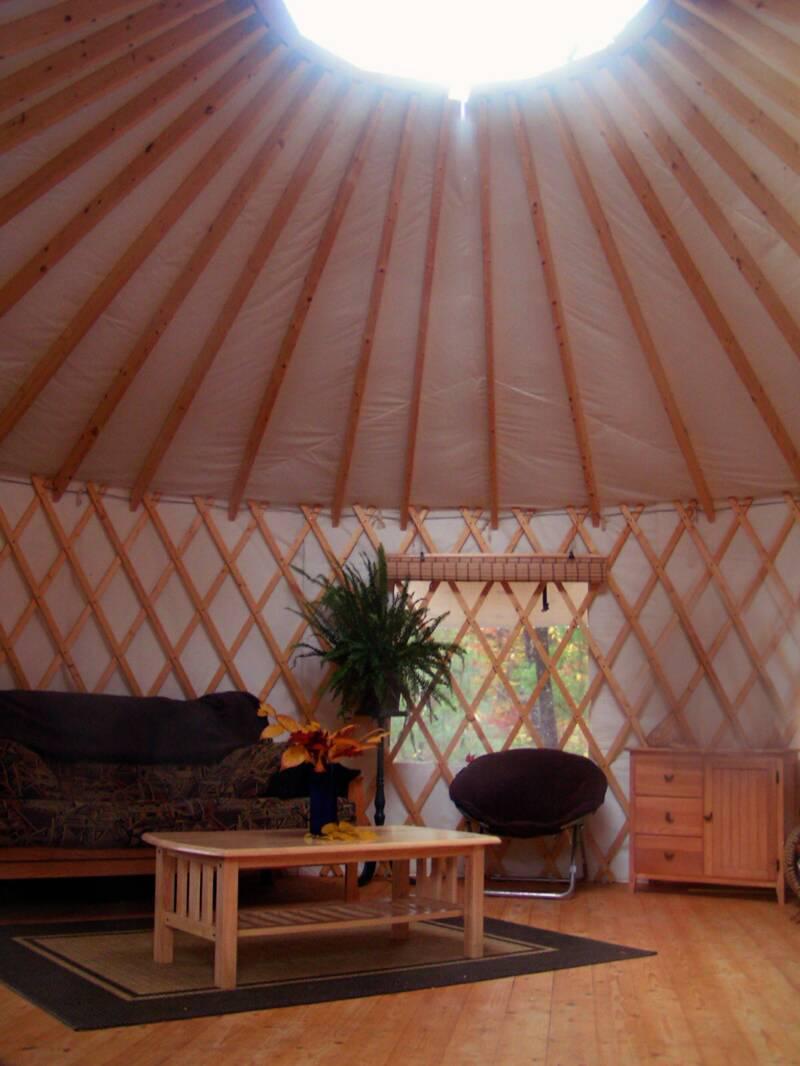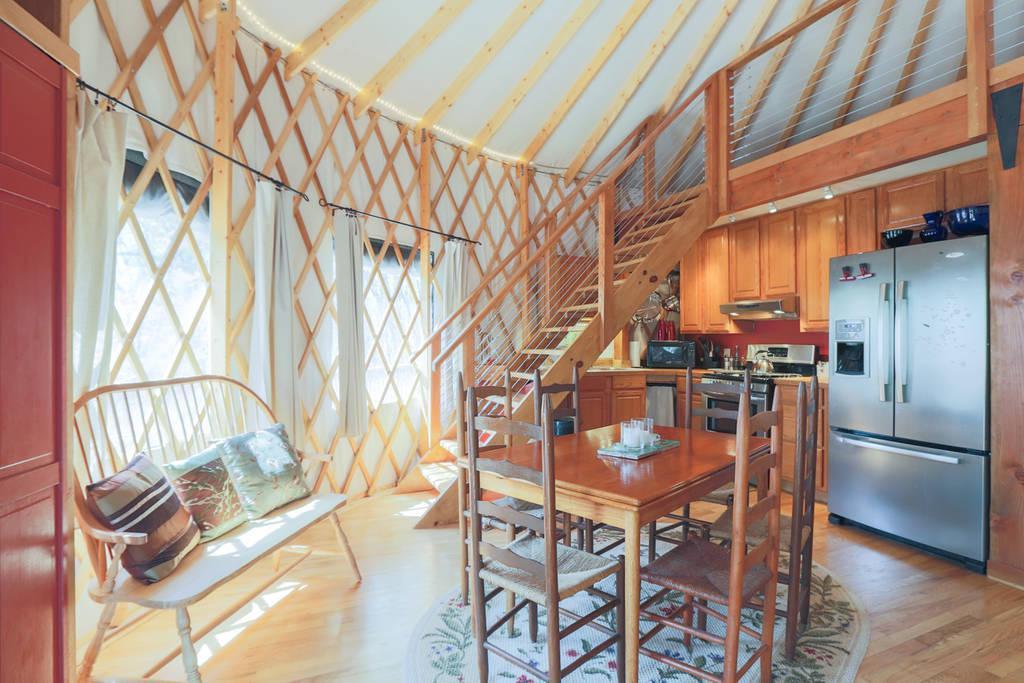The first image is the image on the left, the second image is the image on the right. For the images shown, is this caption "One of the images contains the exterior of a yurt." true? Answer yes or no. No. The first image is the image on the left, the second image is the image on the right. Examine the images to the left and right. Is the description "The left image features at least one plant with long green leaves near something resembling a table." accurate? Answer yes or no. Yes. 